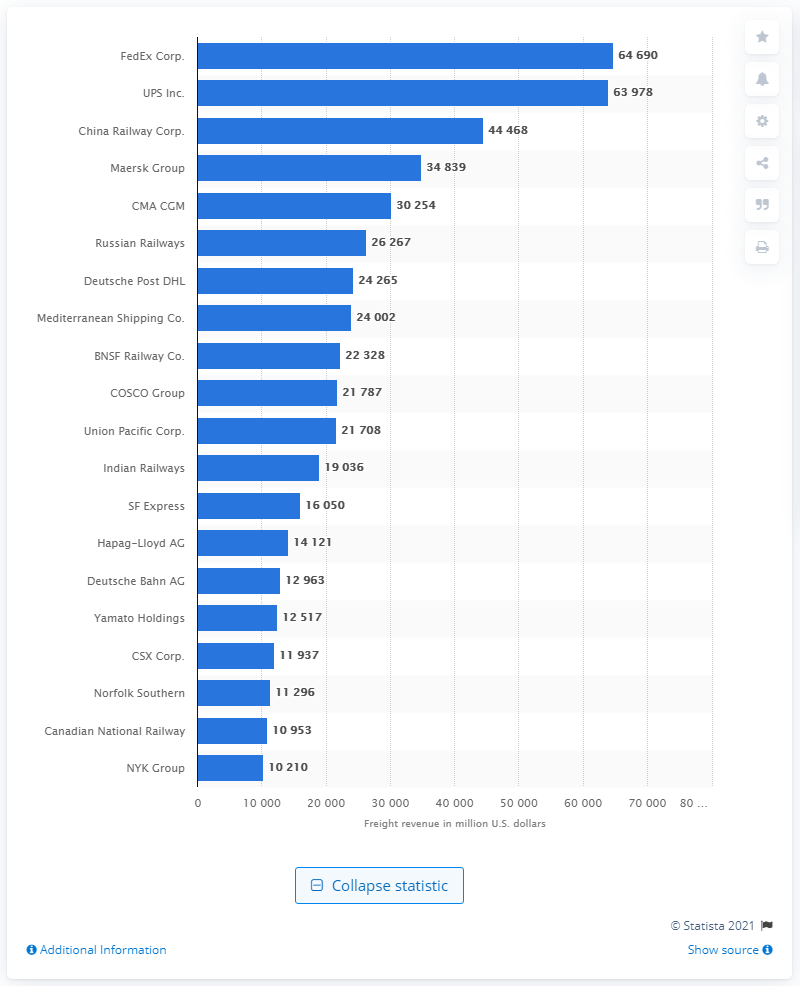Identify some key points in this picture. In 2019, the freight revenue of FedEx was $64,690. 